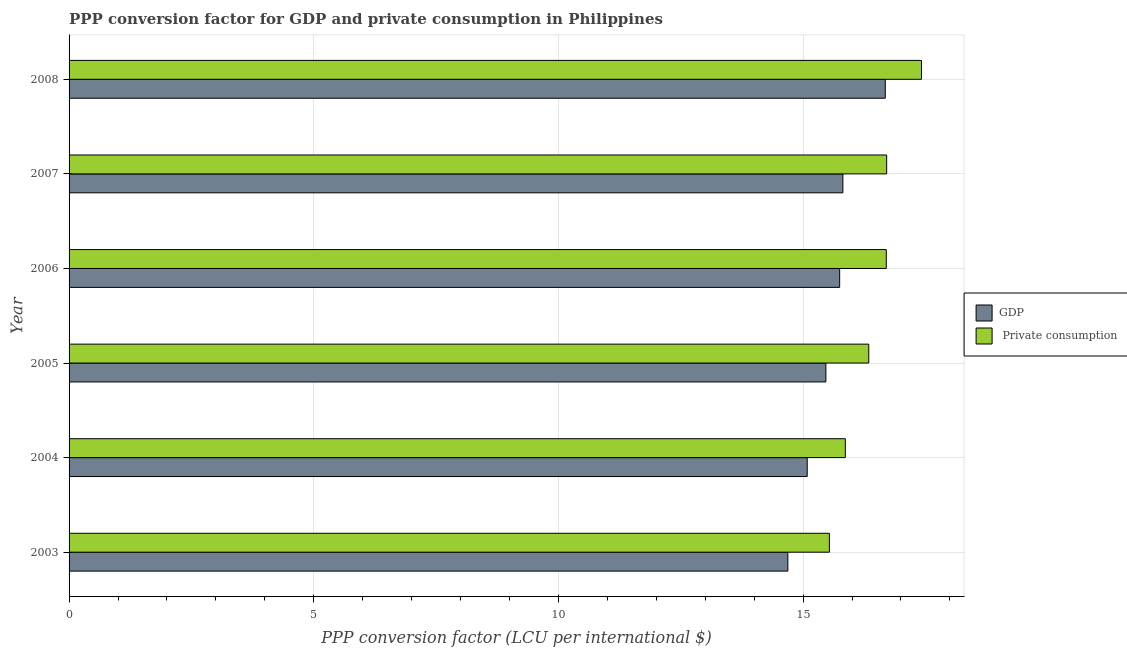How many groups of bars are there?
Provide a succinct answer. 6. Are the number of bars on each tick of the Y-axis equal?
Offer a very short reply. Yes. How many bars are there on the 3rd tick from the bottom?
Offer a terse response. 2. What is the label of the 5th group of bars from the top?
Offer a very short reply. 2004. In how many cases, is the number of bars for a given year not equal to the number of legend labels?
Give a very brief answer. 0. What is the ppp conversion factor for gdp in 2004?
Your answer should be compact. 15.08. Across all years, what is the maximum ppp conversion factor for gdp?
Ensure brevity in your answer.  16.68. Across all years, what is the minimum ppp conversion factor for gdp?
Your answer should be very brief. 14.69. What is the total ppp conversion factor for gdp in the graph?
Provide a short and direct response. 93.48. What is the difference between the ppp conversion factor for gdp in 2004 and that in 2005?
Your response must be concise. -0.38. What is the difference between the ppp conversion factor for private consumption in 2005 and the ppp conversion factor for gdp in 2007?
Provide a short and direct response. 0.53. What is the average ppp conversion factor for private consumption per year?
Your answer should be very brief. 16.43. In the year 2003, what is the difference between the ppp conversion factor for private consumption and ppp conversion factor for gdp?
Offer a terse response. 0.85. In how many years, is the ppp conversion factor for private consumption greater than 13 LCU?
Make the answer very short. 6. What is the ratio of the ppp conversion factor for gdp in 2005 to that in 2006?
Provide a succinct answer. 0.98. Is the ppp conversion factor for private consumption in 2003 less than that in 2004?
Offer a very short reply. Yes. Is the difference between the ppp conversion factor for gdp in 2005 and 2007 greater than the difference between the ppp conversion factor for private consumption in 2005 and 2007?
Your answer should be compact. Yes. What is the difference between the highest and the second highest ppp conversion factor for gdp?
Keep it short and to the point. 0.87. What is the difference between the highest and the lowest ppp conversion factor for private consumption?
Offer a terse response. 1.88. In how many years, is the ppp conversion factor for private consumption greater than the average ppp conversion factor for private consumption taken over all years?
Offer a very short reply. 3. Is the sum of the ppp conversion factor for gdp in 2004 and 2008 greater than the maximum ppp conversion factor for private consumption across all years?
Provide a succinct answer. Yes. What does the 2nd bar from the top in 2003 represents?
Make the answer very short. GDP. What does the 2nd bar from the bottom in 2005 represents?
Your response must be concise.  Private consumption. How many bars are there?
Your response must be concise. 12. How many years are there in the graph?
Give a very brief answer. 6. What is the difference between two consecutive major ticks on the X-axis?
Offer a terse response. 5. Are the values on the major ticks of X-axis written in scientific E-notation?
Your response must be concise. No. Does the graph contain any zero values?
Keep it short and to the point. No. Does the graph contain grids?
Give a very brief answer. Yes. Where does the legend appear in the graph?
Your answer should be very brief. Center right. How many legend labels are there?
Your response must be concise. 2. What is the title of the graph?
Your answer should be compact. PPP conversion factor for GDP and private consumption in Philippines. What is the label or title of the X-axis?
Offer a very short reply. PPP conversion factor (LCU per international $). What is the label or title of the Y-axis?
Make the answer very short. Year. What is the PPP conversion factor (LCU per international $) of GDP in 2003?
Your answer should be very brief. 14.69. What is the PPP conversion factor (LCU per international $) in  Private consumption in 2003?
Give a very brief answer. 15.54. What is the PPP conversion factor (LCU per international $) in GDP in 2004?
Your response must be concise. 15.08. What is the PPP conversion factor (LCU per international $) of  Private consumption in 2004?
Your response must be concise. 15.86. What is the PPP conversion factor (LCU per international $) in GDP in 2005?
Give a very brief answer. 15.47. What is the PPP conversion factor (LCU per international $) of  Private consumption in 2005?
Ensure brevity in your answer.  16.34. What is the PPP conversion factor (LCU per international $) of GDP in 2006?
Provide a short and direct response. 15.75. What is the PPP conversion factor (LCU per international $) of  Private consumption in 2006?
Offer a very short reply. 16.7. What is the PPP conversion factor (LCU per international $) of GDP in 2007?
Provide a succinct answer. 15.81. What is the PPP conversion factor (LCU per international $) in  Private consumption in 2007?
Offer a very short reply. 16.71. What is the PPP conversion factor (LCU per international $) in GDP in 2008?
Keep it short and to the point. 16.68. What is the PPP conversion factor (LCU per international $) in  Private consumption in 2008?
Provide a succinct answer. 17.42. Across all years, what is the maximum PPP conversion factor (LCU per international $) of GDP?
Offer a very short reply. 16.68. Across all years, what is the maximum PPP conversion factor (LCU per international $) in  Private consumption?
Offer a terse response. 17.42. Across all years, what is the minimum PPP conversion factor (LCU per international $) of GDP?
Offer a terse response. 14.69. Across all years, what is the minimum PPP conversion factor (LCU per international $) in  Private consumption?
Your answer should be very brief. 15.54. What is the total PPP conversion factor (LCU per international $) in GDP in the graph?
Offer a very short reply. 93.48. What is the total PPP conversion factor (LCU per international $) in  Private consumption in the graph?
Your answer should be very brief. 98.57. What is the difference between the PPP conversion factor (LCU per international $) in GDP in 2003 and that in 2004?
Provide a short and direct response. -0.4. What is the difference between the PPP conversion factor (LCU per international $) of  Private consumption in 2003 and that in 2004?
Make the answer very short. -0.33. What is the difference between the PPP conversion factor (LCU per international $) of GDP in 2003 and that in 2005?
Provide a short and direct response. -0.78. What is the difference between the PPP conversion factor (LCU per international $) in  Private consumption in 2003 and that in 2005?
Keep it short and to the point. -0.81. What is the difference between the PPP conversion factor (LCU per international $) of GDP in 2003 and that in 2006?
Keep it short and to the point. -1.06. What is the difference between the PPP conversion factor (LCU per international $) in  Private consumption in 2003 and that in 2006?
Give a very brief answer. -1.16. What is the difference between the PPP conversion factor (LCU per international $) in GDP in 2003 and that in 2007?
Provide a short and direct response. -1.12. What is the difference between the PPP conversion factor (LCU per international $) of  Private consumption in 2003 and that in 2007?
Provide a short and direct response. -1.17. What is the difference between the PPP conversion factor (LCU per international $) in GDP in 2003 and that in 2008?
Make the answer very short. -1.99. What is the difference between the PPP conversion factor (LCU per international $) in  Private consumption in 2003 and that in 2008?
Make the answer very short. -1.88. What is the difference between the PPP conversion factor (LCU per international $) of GDP in 2004 and that in 2005?
Your response must be concise. -0.38. What is the difference between the PPP conversion factor (LCU per international $) of  Private consumption in 2004 and that in 2005?
Keep it short and to the point. -0.48. What is the difference between the PPP conversion factor (LCU per international $) of GDP in 2004 and that in 2006?
Offer a very short reply. -0.66. What is the difference between the PPP conversion factor (LCU per international $) in  Private consumption in 2004 and that in 2006?
Make the answer very short. -0.84. What is the difference between the PPP conversion factor (LCU per international $) of GDP in 2004 and that in 2007?
Your answer should be compact. -0.73. What is the difference between the PPP conversion factor (LCU per international $) in  Private consumption in 2004 and that in 2007?
Keep it short and to the point. -0.84. What is the difference between the PPP conversion factor (LCU per international $) in GDP in 2004 and that in 2008?
Ensure brevity in your answer.  -1.6. What is the difference between the PPP conversion factor (LCU per international $) of  Private consumption in 2004 and that in 2008?
Your answer should be compact. -1.56. What is the difference between the PPP conversion factor (LCU per international $) of GDP in 2005 and that in 2006?
Provide a short and direct response. -0.28. What is the difference between the PPP conversion factor (LCU per international $) in  Private consumption in 2005 and that in 2006?
Give a very brief answer. -0.36. What is the difference between the PPP conversion factor (LCU per international $) in GDP in 2005 and that in 2007?
Offer a terse response. -0.35. What is the difference between the PPP conversion factor (LCU per international $) of  Private consumption in 2005 and that in 2007?
Offer a very short reply. -0.37. What is the difference between the PPP conversion factor (LCU per international $) in GDP in 2005 and that in 2008?
Offer a terse response. -1.21. What is the difference between the PPP conversion factor (LCU per international $) of  Private consumption in 2005 and that in 2008?
Offer a very short reply. -1.08. What is the difference between the PPP conversion factor (LCU per international $) in GDP in 2006 and that in 2007?
Offer a very short reply. -0.07. What is the difference between the PPP conversion factor (LCU per international $) in  Private consumption in 2006 and that in 2007?
Keep it short and to the point. -0.01. What is the difference between the PPP conversion factor (LCU per international $) of GDP in 2006 and that in 2008?
Provide a short and direct response. -0.93. What is the difference between the PPP conversion factor (LCU per international $) of  Private consumption in 2006 and that in 2008?
Your response must be concise. -0.72. What is the difference between the PPP conversion factor (LCU per international $) in GDP in 2007 and that in 2008?
Provide a short and direct response. -0.87. What is the difference between the PPP conversion factor (LCU per international $) in  Private consumption in 2007 and that in 2008?
Provide a succinct answer. -0.71. What is the difference between the PPP conversion factor (LCU per international $) in GDP in 2003 and the PPP conversion factor (LCU per international $) in  Private consumption in 2004?
Keep it short and to the point. -1.17. What is the difference between the PPP conversion factor (LCU per international $) of GDP in 2003 and the PPP conversion factor (LCU per international $) of  Private consumption in 2005?
Your response must be concise. -1.65. What is the difference between the PPP conversion factor (LCU per international $) in GDP in 2003 and the PPP conversion factor (LCU per international $) in  Private consumption in 2006?
Offer a terse response. -2.01. What is the difference between the PPP conversion factor (LCU per international $) of GDP in 2003 and the PPP conversion factor (LCU per international $) of  Private consumption in 2007?
Your answer should be compact. -2.02. What is the difference between the PPP conversion factor (LCU per international $) in GDP in 2003 and the PPP conversion factor (LCU per international $) in  Private consumption in 2008?
Your response must be concise. -2.73. What is the difference between the PPP conversion factor (LCU per international $) in GDP in 2004 and the PPP conversion factor (LCU per international $) in  Private consumption in 2005?
Your answer should be very brief. -1.26. What is the difference between the PPP conversion factor (LCU per international $) in GDP in 2004 and the PPP conversion factor (LCU per international $) in  Private consumption in 2006?
Give a very brief answer. -1.62. What is the difference between the PPP conversion factor (LCU per international $) in GDP in 2004 and the PPP conversion factor (LCU per international $) in  Private consumption in 2007?
Your answer should be very brief. -1.62. What is the difference between the PPP conversion factor (LCU per international $) of GDP in 2004 and the PPP conversion factor (LCU per international $) of  Private consumption in 2008?
Provide a short and direct response. -2.33. What is the difference between the PPP conversion factor (LCU per international $) of GDP in 2005 and the PPP conversion factor (LCU per international $) of  Private consumption in 2006?
Provide a short and direct response. -1.23. What is the difference between the PPP conversion factor (LCU per international $) of GDP in 2005 and the PPP conversion factor (LCU per international $) of  Private consumption in 2007?
Offer a terse response. -1.24. What is the difference between the PPP conversion factor (LCU per international $) in GDP in 2005 and the PPP conversion factor (LCU per international $) in  Private consumption in 2008?
Make the answer very short. -1.95. What is the difference between the PPP conversion factor (LCU per international $) in GDP in 2006 and the PPP conversion factor (LCU per international $) in  Private consumption in 2007?
Ensure brevity in your answer.  -0.96. What is the difference between the PPP conversion factor (LCU per international $) of GDP in 2006 and the PPP conversion factor (LCU per international $) of  Private consumption in 2008?
Your answer should be very brief. -1.67. What is the difference between the PPP conversion factor (LCU per international $) of GDP in 2007 and the PPP conversion factor (LCU per international $) of  Private consumption in 2008?
Keep it short and to the point. -1.61. What is the average PPP conversion factor (LCU per international $) in GDP per year?
Provide a succinct answer. 15.58. What is the average PPP conversion factor (LCU per international $) of  Private consumption per year?
Offer a terse response. 16.43. In the year 2003, what is the difference between the PPP conversion factor (LCU per international $) in GDP and PPP conversion factor (LCU per international $) in  Private consumption?
Give a very brief answer. -0.85. In the year 2004, what is the difference between the PPP conversion factor (LCU per international $) in GDP and PPP conversion factor (LCU per international $) in  Private consumption?
Your answer should be very brief. -0.78. In the year 2005, what is the difference between the PPP conversion factor (LCU per international $) in GDP and PPP conversion factor (LCU per international $) in  Private consumption?
Offer a very short reply. -0.88. In the year 2006, what is the difference between the PPP conversion factor (LCU per international $) in GDP and PPP conversion factor (LCU per international $) in  Private consumption?
Make the answer very short. -0.95. In the year 2007, what is the difference between the PPP conversion factor (LCU per international $) of GDP and PPP conversion factor (LCU per international $) of  Private consumption?
Offer a terse response. -0.89. In the year 2008, what is the difference between the PPP conversion factor (LCU per international $) in GDP and PPP conversion factor (LCU per international $) in  Private consumption?
Provide a short and direct response. -0.74. What is the ratio of the PPP conversion factor (LCU per international $) of GDP in 2003 to that in 2004?
Give a very brief answer. 0.97. What is the ratio of the PPP conversion factor (LCU per international $) of  Private consumption in 2003 to that in 2004?
Keep it short and to the point. 0.98. What is the ratio of the PPP conversion factor (LCU per international $) in GDP in 2003 to that in 2005?
Provide a succinct answer. 0.95. What is the ratio of the PPP conversion factor (LCU per international $) of  Private consumption in 2003 to that in 2005?
Ensure brevity in your answer.  0.95. What is the ratio of the PPP conversion factor (LCU per international $) in GDP in 2003 to that in 2006?
Give a very brief answer. 0.93. What is the ratio of the PPP conversion factor (LCU per international $) in  Private consumption in 2003 to that in 2006?
Provide a short and direct response. 0.93. What is the ratio of the PPP conversion factor (LCU per international $) of GDP in 2003 to that in 2007?
Make the answer very short. 0.93. What is the ratio of the PPP conversion factor (LCU per international $) of  Private consumption in 2003 to that in 2007?
Your response must be concise. 0.93. What is the ratio of the PPP conversion factor (LCU per international $) in GDP in 2003 to that in 2008?
Offer a very short reply. 0.88. What is the ratio of the PPP conversion factor (LCU per international $) in  Private consumption in 2003 to that in 2008?
Your response must be concise. 0.89. What is the ratio of the PPP conversion factor (LCU per international $) in GDP in 2004 to that in 2005?
Keep it short and to the point. 0.98. What is the ratio of the PPP conversion factor (LCU per international $) in  Private consumption in 2004 to that in 2005?
Ensure brevity in your answer.  0.97. What is the ratio of the PPP conversion factor (LCU per international $) in GDP in 2004 to that in 2006?
Make the answer very short. 0.96. What is the ratio of the PPP conversion factor (LCU per international $) in  Private consumption in 2004 to that in 2006?
Make the answer very short. 0.95. What is the ratio of the PPP conversion factor (LCU per international $) in GDP in 2004 to that in 2007?
Keep it short and to the point. 0.95. What is the ratio of the PPP conversion factor (LCU per international $) of  Private consumption in 2004 to that in 2007?
Keep it short and to the point. 0.95. What is the ratio of the PPP conversion factor (LCU per international $) in GDP in 2004 to that in 2008?
Provide a succinct answer. 0.9. What is the ratio of the PPP conversion factor (LCU per international $) of  Private consumption in 2004 to that in 2008?
Offer a very short reply. 0.91. What is the ratio of the PPP conversion factor (LCU per international $) of GDP in 2005 to that in 2006?
Your response must be concise. 0.98. What is the ratio of the PPP conversion factor (LCU per international $) in  Private consumption in 2005 to that in 2006?
Offer a very short reply. 0.98. What is the ratio of the PPP conversion factor (LCU per international $) of  Private consumption in 2005 to that in 2007?
Your answer should be compact. 0.98. What is the ratio of the PPP conversion factor (LCU per international $) in GDP in 2005 to that in 2008?
Your response must be concise. 0.93. What is the ratio of the PPP conversion factor (LCU per international $) in  Private consumption in 2005 to that in 2008?
Keep it short and to the point. 0.94. What is the ratio of the PPP conversion factor (LCU per international $) of GDP in 2006 to that in 2008?
Offer a very short reply. 0.94. What is the ratio of the PPP conversion factor (LCU per international $) in  Private consumption in 2006 to that in 2008?
Provide a succinct answer. 0.96. What is the ratio of the PPP conversion factor (LCU per international $) in GDP in 2007 to that in 2008?
Your answer should be compact. 0.95. What is the ratio of the PPP conversion factor (LCU per international $) in  Private consumption in 2007 to that in 2008?
Make the answer very short. 0.96. What is the difference between the highest and the second highest PPP conversion factor (LCU per international $) in GDP?
Make the answer very short. 0.87. What is the difference between the highest and the second highest PPP conversion factor (LCU per international $) in  Private consumption?
Provide a succinct answer. 0.71. What is the difference between the highest and the lowest PPP conversion factor (LCU per international $) of GDP?
Offer a terse response. 1.99. What is the difference between the highest and the lowest PPP conversion factor (LCU per international $) of  Private consumption?
Keep it short and to the point. 1.88. 